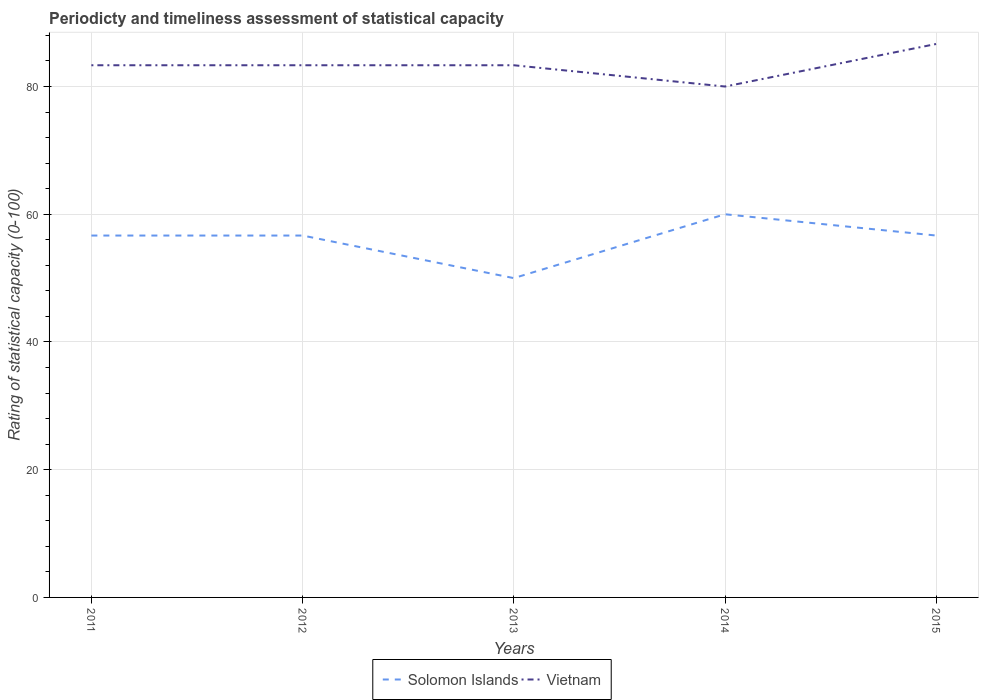How many different coloured lines are there?
Your answer should be very brief. 2. Does the line corresponding to Solomon Islands intersect with the line corresponding to Vietnam?
Your answer should be very brief. No. In which year was the rating of statistical capacity in Solomon Islands maximum?
Keep it short and to the point. 2013. What is the total rating of statistical capacity in Solomon Islands in the graph?
Your answer should be very brief. -6.67. What is the difference between the highest and the second highest rating of statistical capacity in Vietnam?
Keep it short and to the point. 6.67. What is the difference between two consecutive major ticks on the Y-axis?
Ensure brevity in your answer.  20. Does the graph contain grids?
Keep it short and to the point. Yes. How many legend labels are there?
Offer a very short reply. 2. What is the title of the graph?
Make the answer very short. Periodicty and timeliness assessment of statistical capacity. What is the label or title of the X-axis?
Your answer should be compact. Years. What is the label or title of the Y-axis?
Offer a terse response. Rating of statistical capacity (0-100). What is the Rating of statistical capacity (0-100) of Solomon Islands in 2011?
Ensure brevity in your answer.  56.67. What is the Rating of statistical capacity (0-100) of Vietnam in 2011?
Offer a terse response. 83.33. What is the Rating of statistical capacity (0-100) of Solomon Islands in 2012?
Keep it short and to the point. 56.67. What is the Rating of statistical capacity (0-100) of Vietnam in 2012?
Provide a succinct answer. 83.33. What is the Rating of statistical capacity (0-100) of Solomon Islands in 2013?
Provide a succinct answer. 50. What is the Rating of statistical capacity (0-100) of Vietnam in 2013?
Your answer should be compact. 83.33. What is the Rating of statistical capacity (0-100) of Solomon Islands in 2014?
Offer a very short reply. 60. What is the Rating of statistical capacity (0-100) of Vietnam in 2014?
Give a very brief answer. 80. What is the Rating of statistical capacity (0-100) of Solomon Islands in 2015?
Make the answer very short. 56.67. What is the Rating of statistical capacity (0-100) in Vietnam in 2015?
Make the answer very short. 86.67. Across all years, what is the maximum Rating of statistical capacity (0-100) of Vietnam?
Your response must be concise. 86.67. Across all years, what is the minimum Rating of statistical capacity (0-100) in Solomon Islands?
Provide a short and direct response. 50. Across all years, what is the minimum Rating of statistical capacity (0-100) of Vietnam?
Make the answer very short. 80. What is the total Rating of statistical capacity (0-100) in Solomon Islands in the graph?
Make the answer very short. 280. What is the total Rating of statistical capacity (0-100) in Vietnam in the graph?
Offer a very short reply. 416.67. What is the difference between the Rating of statistical capacity (0-100) in Solomon Islands in 2011 and that in 2013?
Make the answer very short. 6.67. What is the difference between the Rating of statistical capacity (0-100) in Vietnam in 2011 and that in 2013?
Your response must be concise. -0. What is the difference between the Rating of statistical capacity (0-100) of Vietnam in 2011 and that in 2014?
Give a very brief answer. 3.33. What is the difference between the Rating of statistical capacity (0-100) in Vietnam in 2011 and that in 2015?
Offer a terse response. -3.33. What is the difference between the Rating of statistical capacity (0-100) of Vietnam in 2012 and that in 2014?
Give a very brief answer. 3.33. What is the difference between the Rating of statistical capacity (0-100) of Solomon Islands in 2012 and that in 2015?
Your answer should be compact. 0. What is the difference between the Rating of statistical capacity (0-100) in Vietnam in 2012 and that in 2015?
Provide a succinct answer. -3.33. What is the difference between the Rating of statistical capacity (0-100) in Solomon Islands in 2013 and that in 2015?
Your answer should be compact. -6.67. What is the difference between the Rating of statistical capacity (0-100) in Vietnam in 2013 and that in 2015?
Offer a terse response. -3.33. What is the difference between the Rating of statistical capacity (0-100) in Solomon Islands in 2014 and that in 2015?
Your answer should be very brief. 3.33. What is the difference between the Rating of statistical capacity (0-100) of Vietnam in 2014 and that in 2015?
Keep it short and to the point. -6.67. What is the difference between the Rating of statistical capacity (0-100) in Solomon Islands in 2011 and the Rating of statistical capacity (0-100) in Vietnam in 2012?
Your answer should be compact. -26.67. What is the difference between the Rating of statistical capacity (0-100) in Solomon Islands in 2011 and the Rating of statistical capacity (0-100) in Vietnam in 2013?
Your answer should be very brief. -26.67. What is the difference between the Rating of statistical capacity (0-100) in Solomon Islands in 2011 and the Rating of statistical capacity (0-100) in Vietnam in 2014?
Offer a terse response. -23.33. What is the difference between the Rating of statistical capacity (0-100) of Solomon Islands in 2011 and the Rating of statistical capacity (0-100) of Vietnam in 2015?
Give a very brief answer. -30. What is the difference between the Rating of statistical capacity (0-100) of Solomon Islands in 2012 and the Rating of statistical capacity (0-100) of Vietnam in 2013?
Offer a very short reply. -26.67. What is the difference between the Rating of statistical capacity (0-100) of Solomon Islands in 2012 and the Rating of statistical capacity (0-100) of Vietnam in 2014?
Your response must be concise. -23.33. What is the difference between the Rating of statistical capacity (0-100) in Solomon Islands in 2013 and the Rating of statistical capacity (0-100) in Vietnam in 2015?
Your response must be concise. -36.67. What is the difference between the Rating of statistical capacity (0-100) in Solomon Islands in 2014 and the Rating of statistical capacity (0-100) in Vietnam in 2015?
Your answer should be compact. -26.67. What is the average Rating of statistical capacity (0-100) in Solomon Islands per year?
Keep it short and to the point. 56. What is the average Rating of statistical capacity (0-100) in Vietnam per year?
Give a very brief answer. 83.33. In the year 2011, what is the difference between the Rating of statistical capacity (0-100) in Solomon Islands and Rating of statistical capacity (0-100) in Vietnam?
Your response must be concise. -26.67. In the year 2012, what is the difference between the Rating of statistical capacity (0-100) in Solomon Islands and Rating of statistical capacity (0-100) in Vietnam?
Give a very brief answer. -26.67. In the year 2013, what is the difference between the Rating of statistical capacity (0-100) in Solomon Islands and Rating of statistical capacity (0-100) in Vietnam?
Offer a very short reply. -33.33. In the year 2015, what is the difference between the Rating of statistical capacity (0-100) of Solomon Islands and Rating of statistical capacity (0-100) of Vietnam?
Ensure brevity in your answer.  -30. What is the ratio of the Rating of statistical capacity (0-100) of Solomon Islands in 2011 to that in 2012?
Your answer should be very brief. 1. What is the ratio of the Rating of statistical capacity (0-100) in Vietnam in 2011 to that in 2012?
Offer a terse response. 1. What is the ratio of the Rating of statistical capacity (0-100) of Solomon Islands in 2011 to that in 2013?
Your answer should be very brief. 1.13. What is the ratio of the Rating of statistical capacity (0-100) in Vietnam in 2011 to that in 2014?
Provide a succinct answer. 1.04. What is the ratio of the Rating of statistical capacity (0-100) in Solomon Islands in 2011 to that in 2015?
Give a very brief answer. 1. What is the ratio of the Rating of statistical capacity (0-100) of Vietnam in 2011 to that in 2015?
Your answer should be very brief. 0.96. What is the ratio of the Rating of statistical capacity (0-100) of Solomon Islands in 2012 to that in 2013?
Offer a very short reply. 1.13. What is the ratio of the Rating of statistical capacity (0-100) of Vietnam in 2012 to that in 2013?
Keep it short and to the point. 1. What is the ratio of the Rating of statistical capacity (0-100) of Vietnam in 2012 to that in 2014?
Your answer should be very brief. 1.04. What is the ratio of the Rating of statistical capacity (0-100) of Vietnam in 2012 to that in 2015?
Give a very brief answer. 0.96. What is the ratio of the Rating of statistical capacity (0-100) in Vietnam in 2013 to that in 2014?
Your answer should be very brief. 1.04. What is the ratio of the Rating of statistical capacity (0-100) of Solomon Islands in 2013 to that in 2015?
Your response must be concise. 0.88. What is the ratio of the Rating of statistical capacity (0-100) of Vietnam in 2013 to that in 2015?
Offer a terse response. 0.96. What is the ratio of the Rating of statistical capacity (0-100) in Solomon Islands in 2014 to that in 2015?
Keep it short and to the point. 1.06. What is the difference between the highest and the second highest Rating of statistical capacity (0-100) in Solomon Islands?
Keep it short and to the point. 3.33. What is the difference between the highest and the second highest Rating of statistical capacity (0-100) of Vietnam?
Provide a short and direct response. 3.33. What is the difference between the highest and the lowest Rating of statistical capacity (0-100) in Vietnam?
Keep it short and to the point. 6.67. 